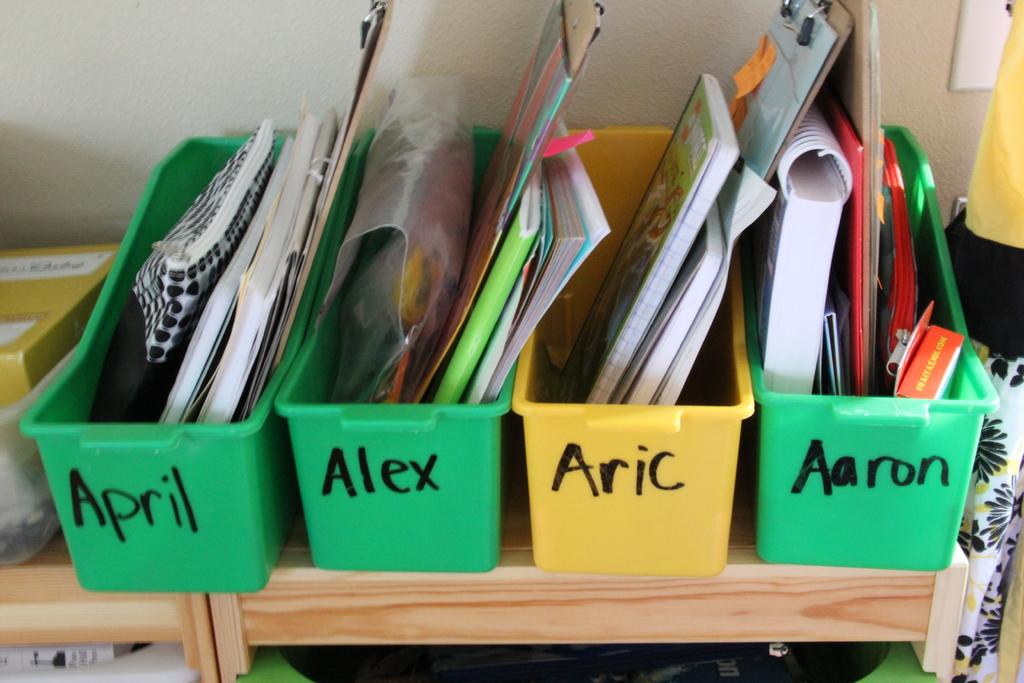What are the names on green bins?
Your answer should be very brief. April, alex, aaron. Which name is ont he yellow bin?
Offer a very short reply. Aric. 